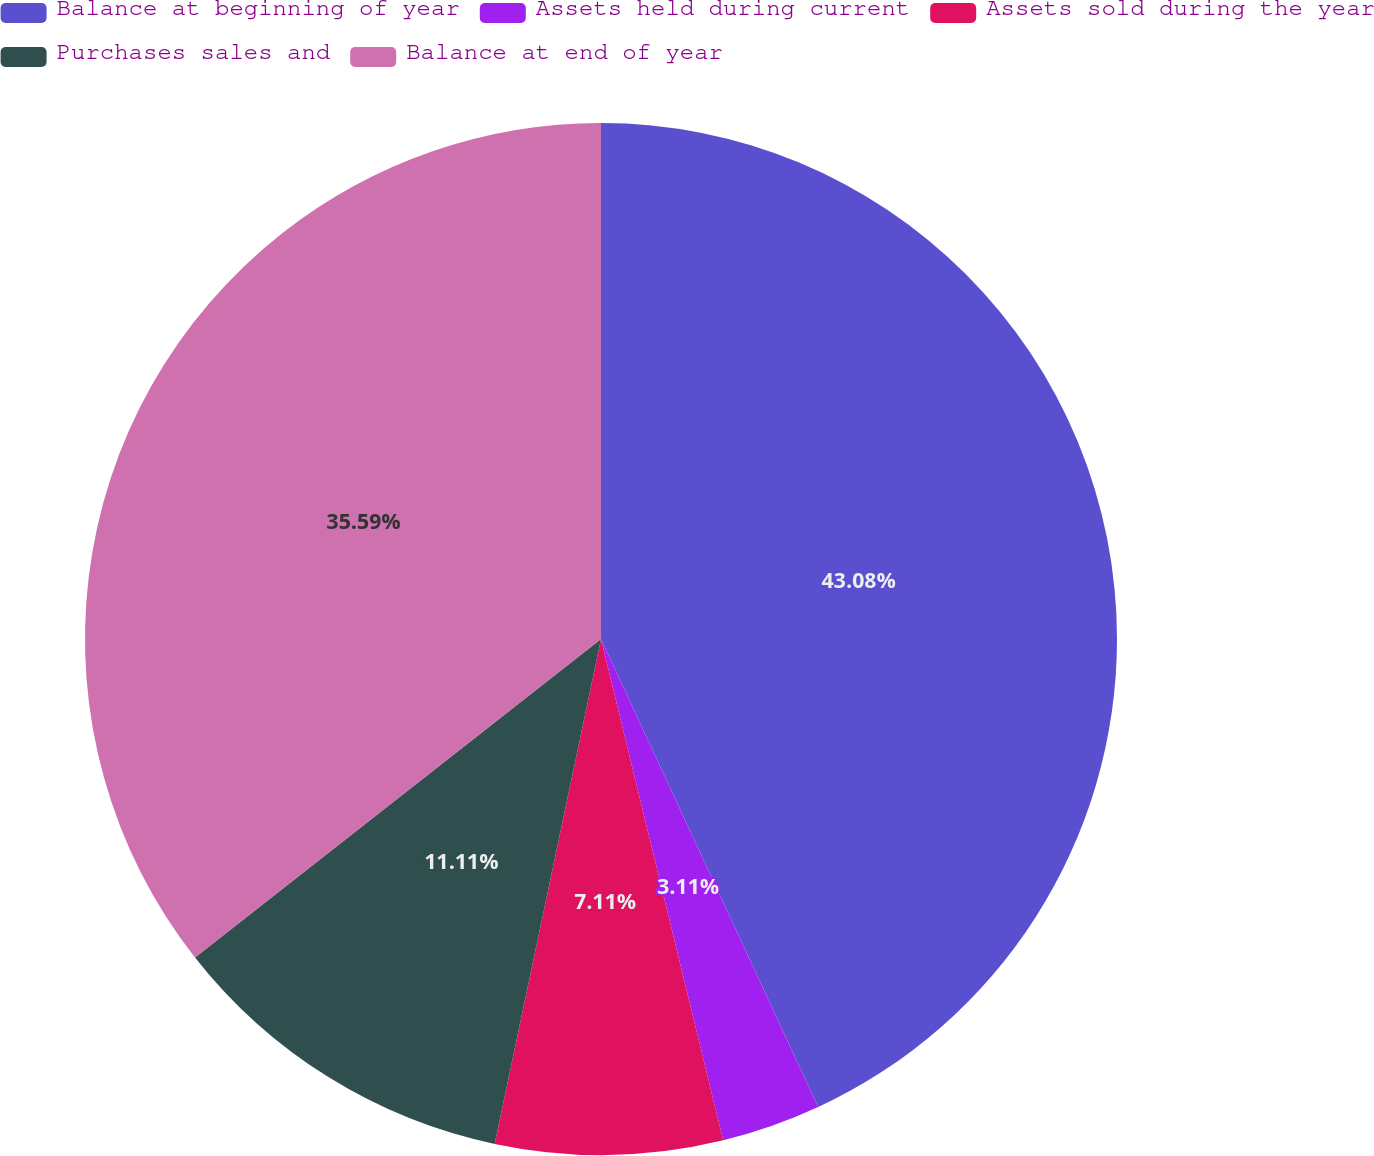<chart> <loc_0><loc_0><loc_500><loc_500><pie_chart><fcel>Balance at beginning of year<fcel>Assets held during current<fcel>Assets sold during the year<fcel>Purchases sales and<fcel>Balance at end of year<nl><fcel>43.09%<fcel>3.11%<fcel>7.11%<fcel>11.11%<fcel>35.59%<nl></chart> 